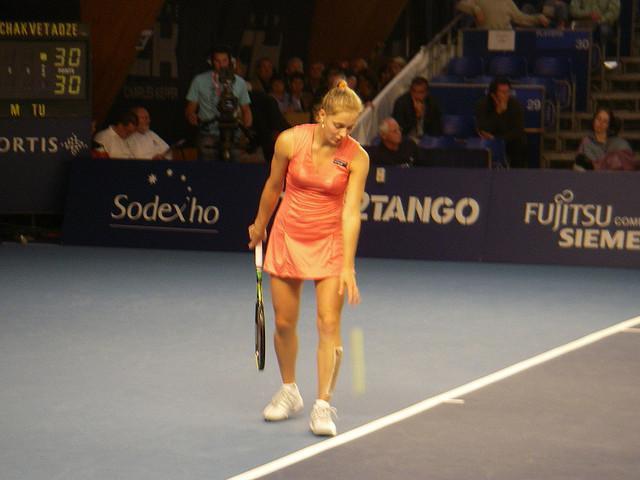How many people are there?
Give a very brief answer. 6. 